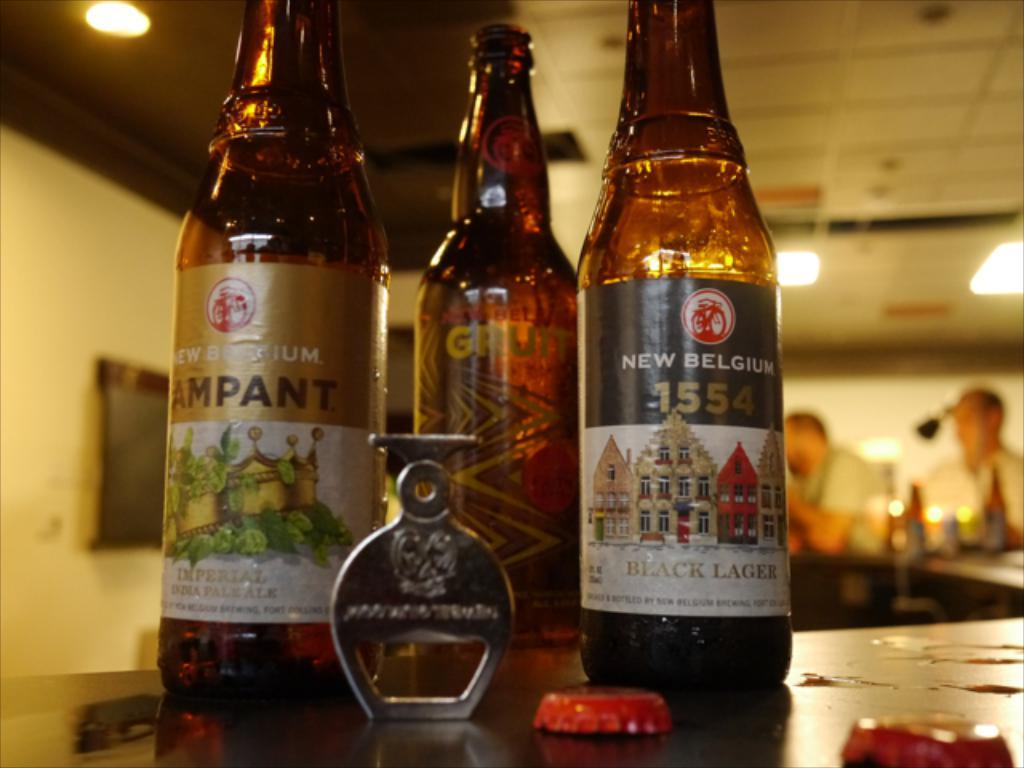Provide a one-sentence caption for the provided image. Several bottles of alcohol, including a black lager selection, sit on a counter. 